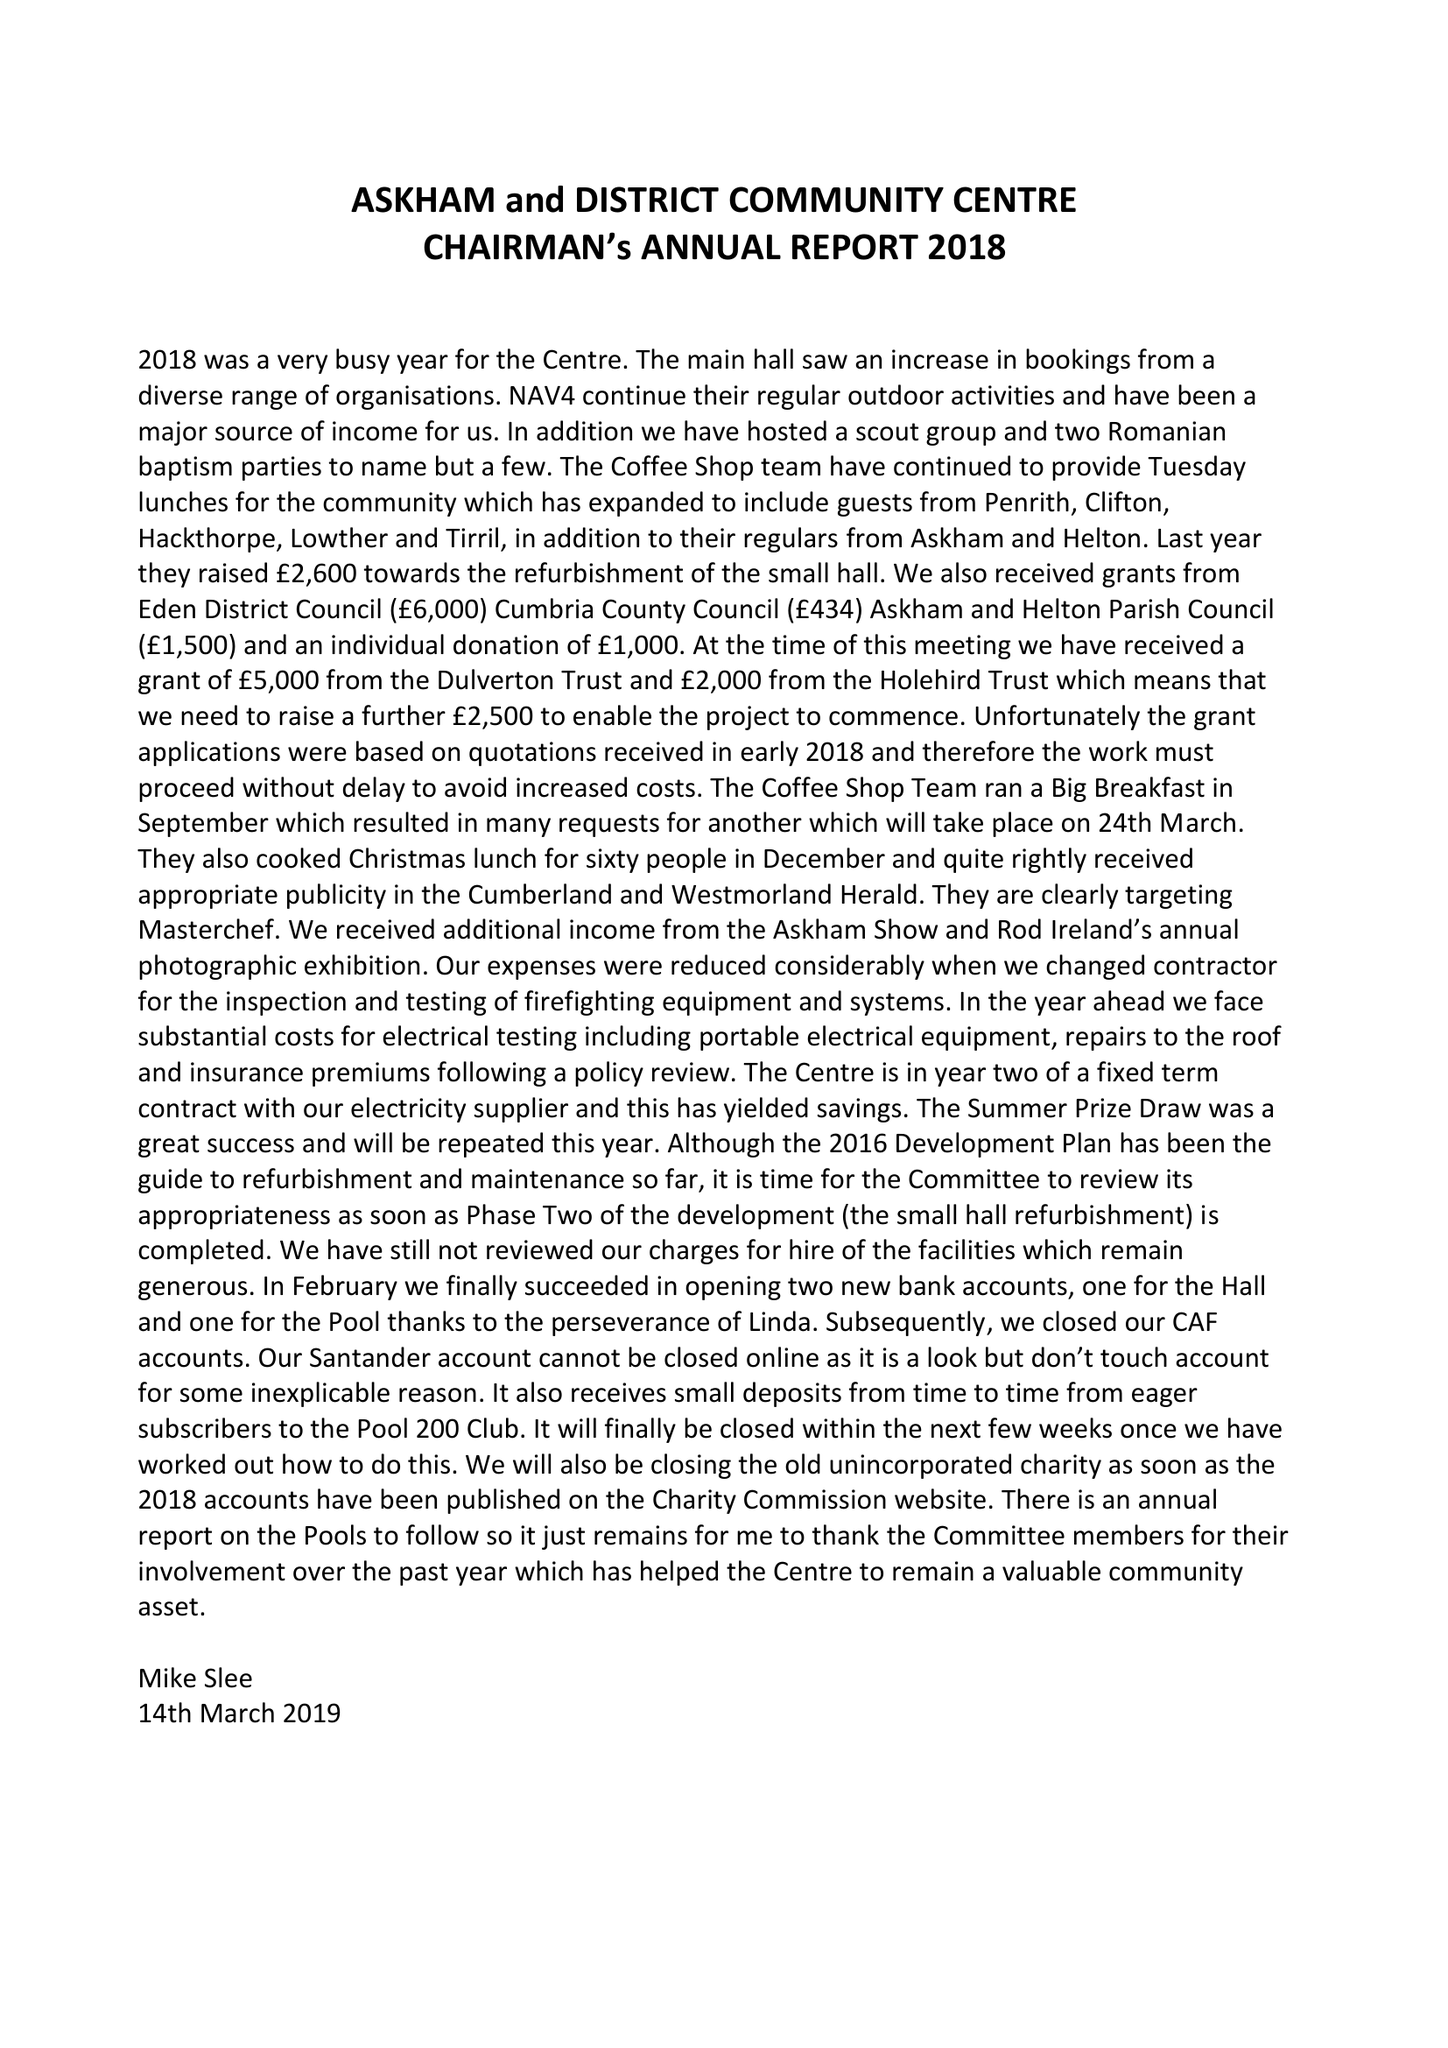What is the value for the report_date?
Answer the question using a single word or phrase. 2018-12-31 